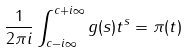<formula> <loc_0><loc_0><loc_500><loc_500>\frac { 1 } { 2 { \pi } i } \int _ { c - i \infty } ^ { c + i \infty } g ( s ) t ^ { s } = \pi ( t )</formula> 